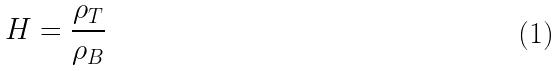Convert formula to latex. <formula><loc_0><loc_0><loc_500><loc_500>H = \frac { \rho _ { T } } { \rho _ { B } }</formula> 